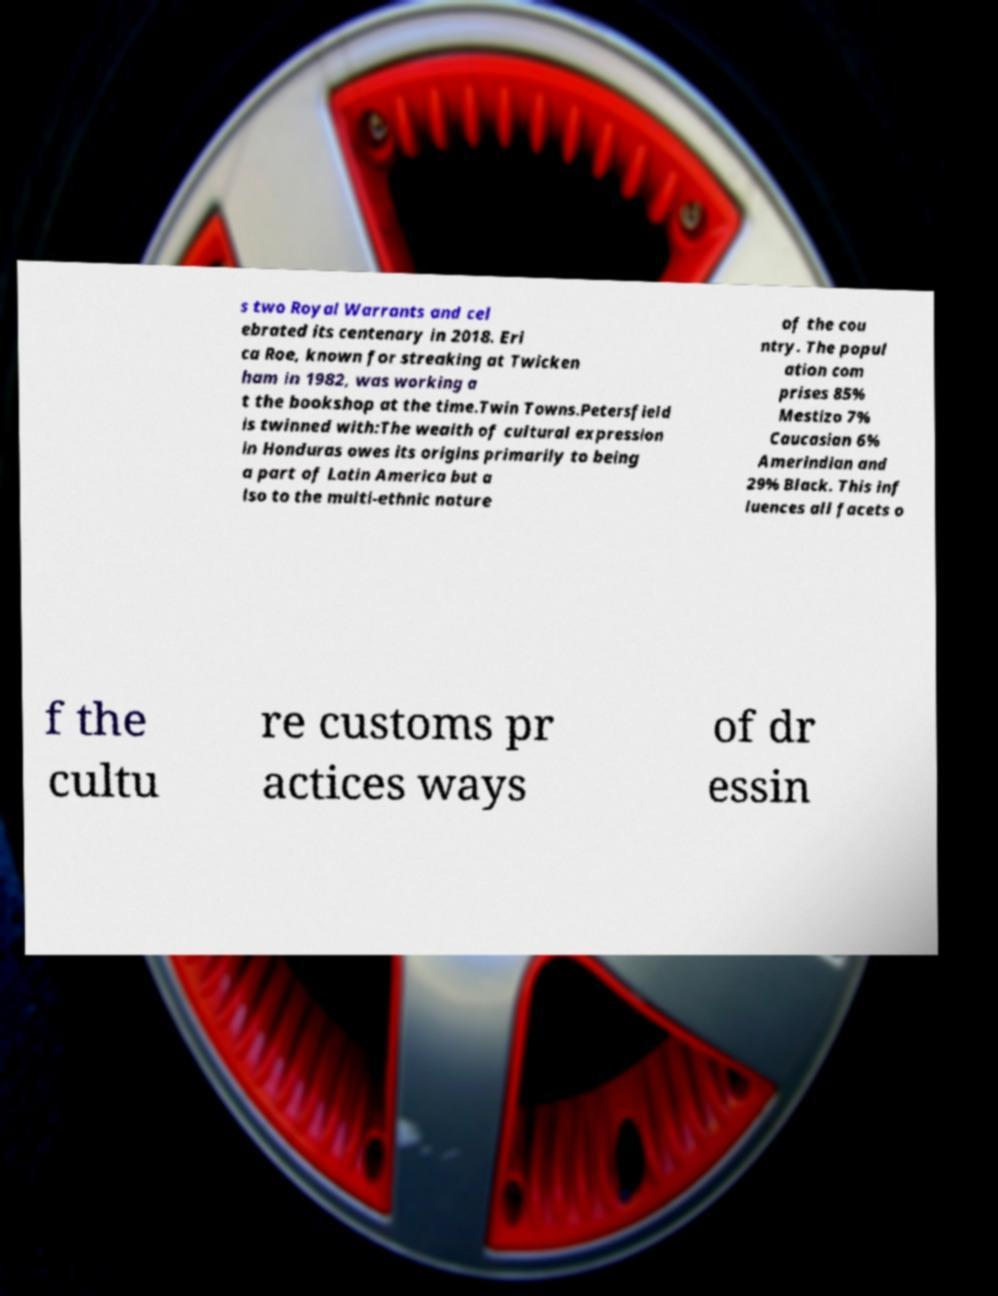I need the written content from this picture converted into text. Can you do that? s two Royal Warrants and cel ebrated its centenary in 2018. Eri ca Roe, known for streaking at Twicken ham in 1982, was working a t the bookshop at the time.Twin Towns.Petersfield is twinned with:The wealth of cultural expression in Honduras owes its origins primarily to being a part of Latin America but a lso to the multi-ethnic nature of the cou ntry. The popul ation com prises 85% Mestizo 7% Caucasian 6% Amerindian and 29% Black. This inf luences all facets o f the cultu re customs pr actices ways of dr essin 